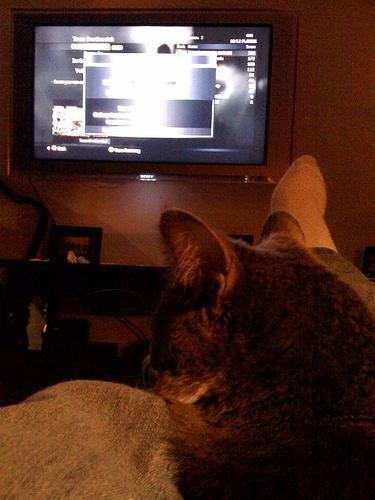How many cats can you see?
Give a very brief answer. 1. How many tvs are there?
Give a very brief answer. 1. 